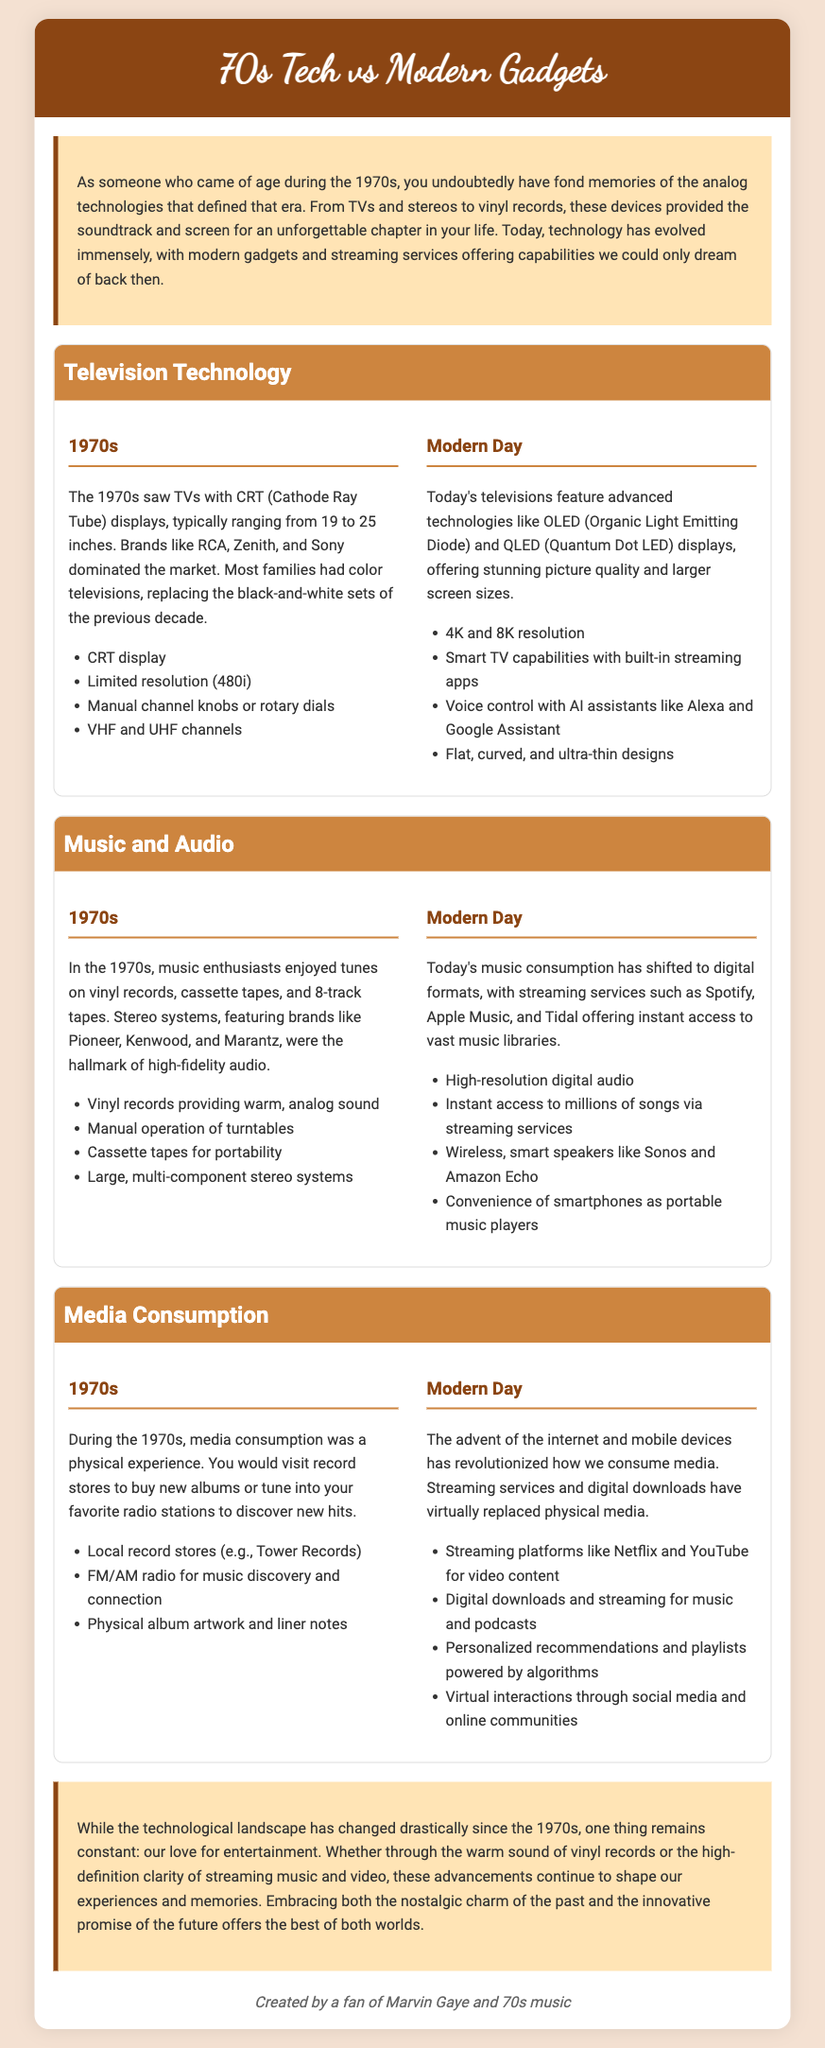What display technology was common in the 1970s? The document states that CRT (Cathode Ray Tube) displays were common in the 1970s.
Answer: CRT What were typical TV sizes in the 1970s? The document mentions that TVs typically ranged from 19 to 25 inches in the 1970s.
Answer: 19 to 25 inches What audio format was primarily used in the 1970s? According to the document, vinyl records were a primary audio format used in the 1970s.
Answer: Vinyl records What type of music systems were popular in the 1970s? The document notes that large, multi-component stereo systems were popular during the 1970s.
Answer: Large, multi-component stereo systems What has replaced physical media in modern media consumption? The document states that streaming services have virtually replaced physical media in modern consumption.
Answer: Streaming services What resolution do modern TVs support? The document mentions that modern TVs support 4K and 8K resolution.
Answer: 4K and 8K Which brands dominated the TV market in the 1970s? The document lists RCA, Zenith, and Sony as dominant brands in the 1970s.
Answer: RCA, Zenith, Sony What has changed about music consumption from the 1970s to modern day? The document explains that music consumption has shifted from vinyl records and tapes to digital formats and streaming services.
Answer: Shifted to digital formats and streaming services How has media interaction evolved from the 1970s to now? The document notes that virtual interactions through social media have become prominent today, replacing traditional methods.
Answer: Virtual interactions through social media 